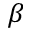Convert formula to latex. <formula><loc_0><loc_0><loc_500><loc_500>\beta</formula> 